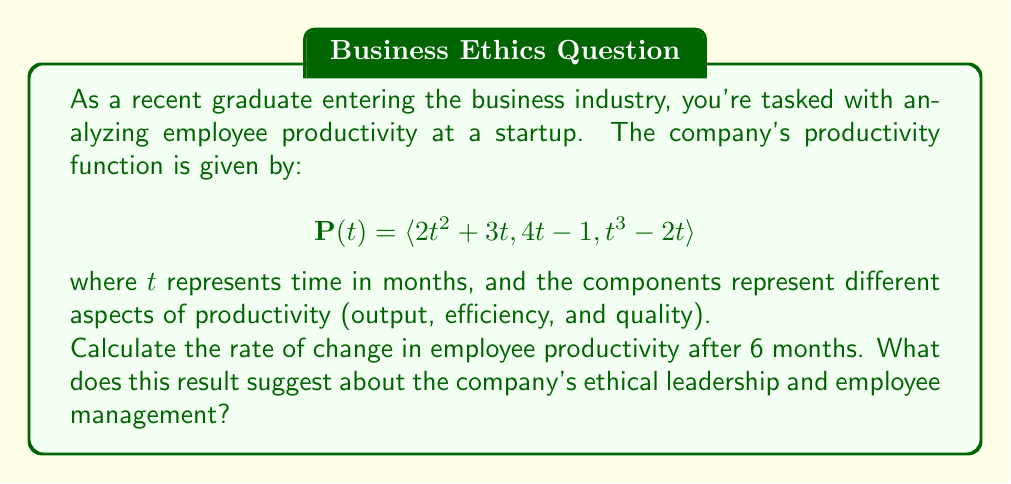Teach me how to tackle this problem. To solve this problem, we need to find the derivative of the vector-valued function $\mathbf{P}(t)$ and then evaluate it at $t = 6$. This will give us the rate of change in productivity after 6 months.

Step 1: Find the derivative of $\mathbf{P}(t)$
The derivative of a vector-valued function is found by differentiating each component:

$$\mathbf{P}'(t) = \langle \frac{d}{dt}(2t^2 + 3t), \frac{d}{dt}(4t - 1), \frac{d}{dt}(t^3 - 2t) \rangle$$

$$\mathbf{P}'(t) = \langle 4t + 3, 4, 3t^2 - 2 \rangle$$

Step 2: Evaluate $\mathbf{P}'(t)$ at $t = 6$
Substitute $t = 6$ into the derivative function:

$$\mathbf{P}'(6) = \langle 4(6) + 3, 4, 3(6)^2 - 2 \rangle$$
$$\mathbf{P}'(6) = \langle 27, 4, 106 \rangle$$

This result represents the rate of change in productivity after 6 months:
- The first component (27) indicates the rate of change in output.
- The second component (4) shows the rate of change in efficiency.
- The third component (106) represents the rate of change in quality.

Interpretation:
The positive values in all components suggest that the company is experiencing growth in all aspects of productivity. However, the significant difference in magnitudes between the components may indicate an imbalance in the company's focus:

1. Output is increasing at a moderate rate (27 units/month).
2. Efficiency is improving slowly but steadily (4 units/month).
3. Quality is improving rapidly (106 units/month).

From an ethical leadership perspective, this result suggests that the company might be prioritizing quality improvement over other aspects of productivity. While this focus on quality is commendable, leaders should ensure that this rapid improvement is not coming at the expense of employee well-being or sustainable practices. They should also consider strategies to boost efficiency growth to match the improvements in output and quality.
Answer: The rate of change in employee productivity after 6 months is $\mathbf{P}'(6) = \langle 27, 4, 106 \rangle$. 